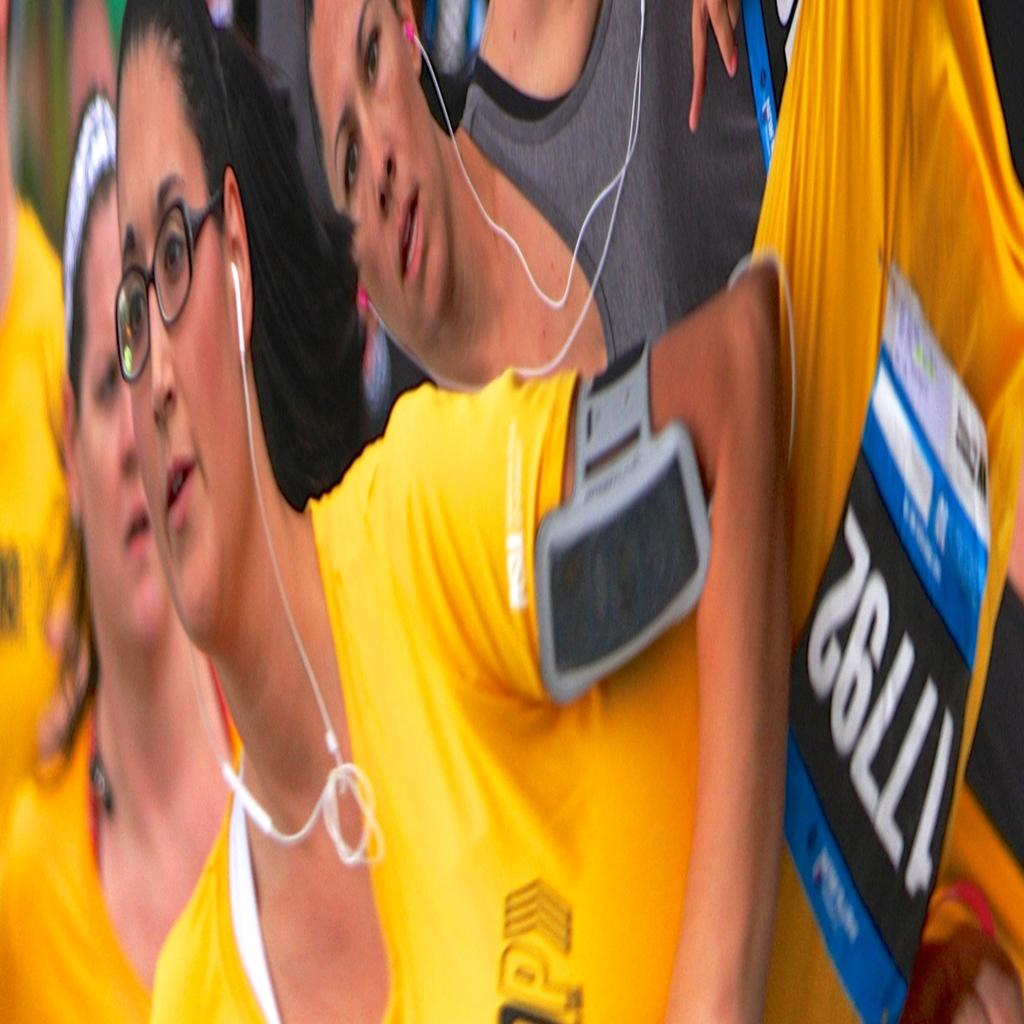How many people are in the image? There are persons in the image. What are the two persons wearing? The two persons are wearing headsets. Can you describe something be seen on one person's hand? Yes, there is a device on a person's hand. What type of beef can be seen on the coast in the image? There is no beef or coast present in the image. What color is the button on the person's shirt in the image? There is no button mentioned in the provided facts, and therefore we cannot determine its color. 